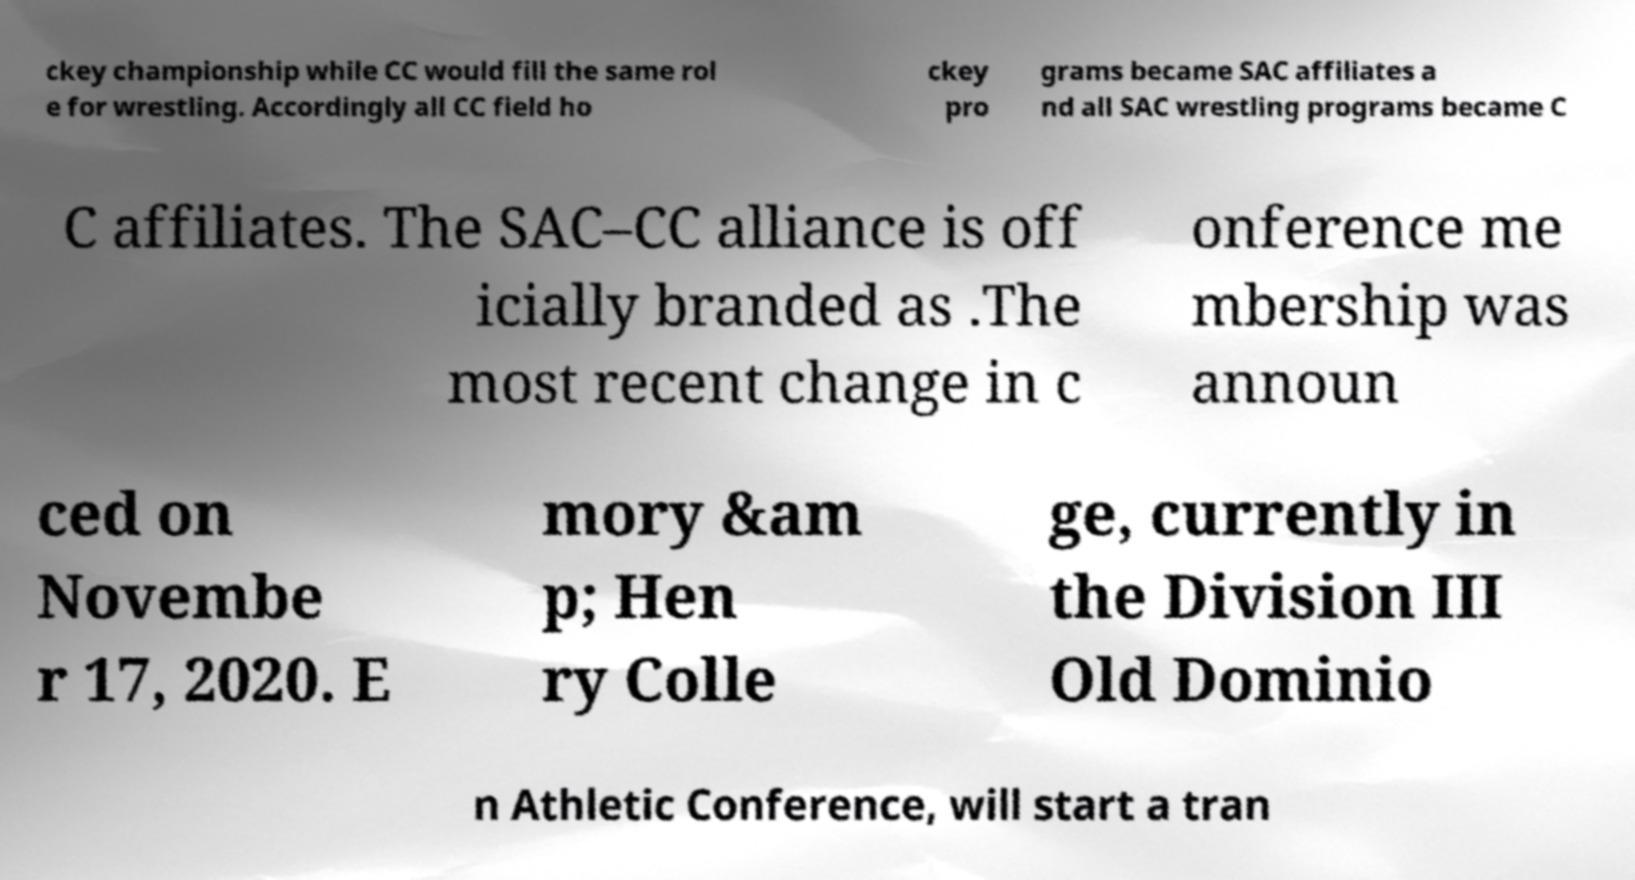I need the written content from this picture converted into text. Can you do that? ckey championship while CC would fill the same rol e for wrestling. Accordingly all CC field ho ckey pro grams became SAC affiliates a nd all SAC wrestling programs became C C affiliates. The SAC–CC alliance is off icially branded as .The most recent change in c onference me mbership was announ ced on Novembe r 17, 2020. E mory &am p; Hen ry Colle ge, currently in the Division III Old Dominio n Athletic Conference, will start a tran 